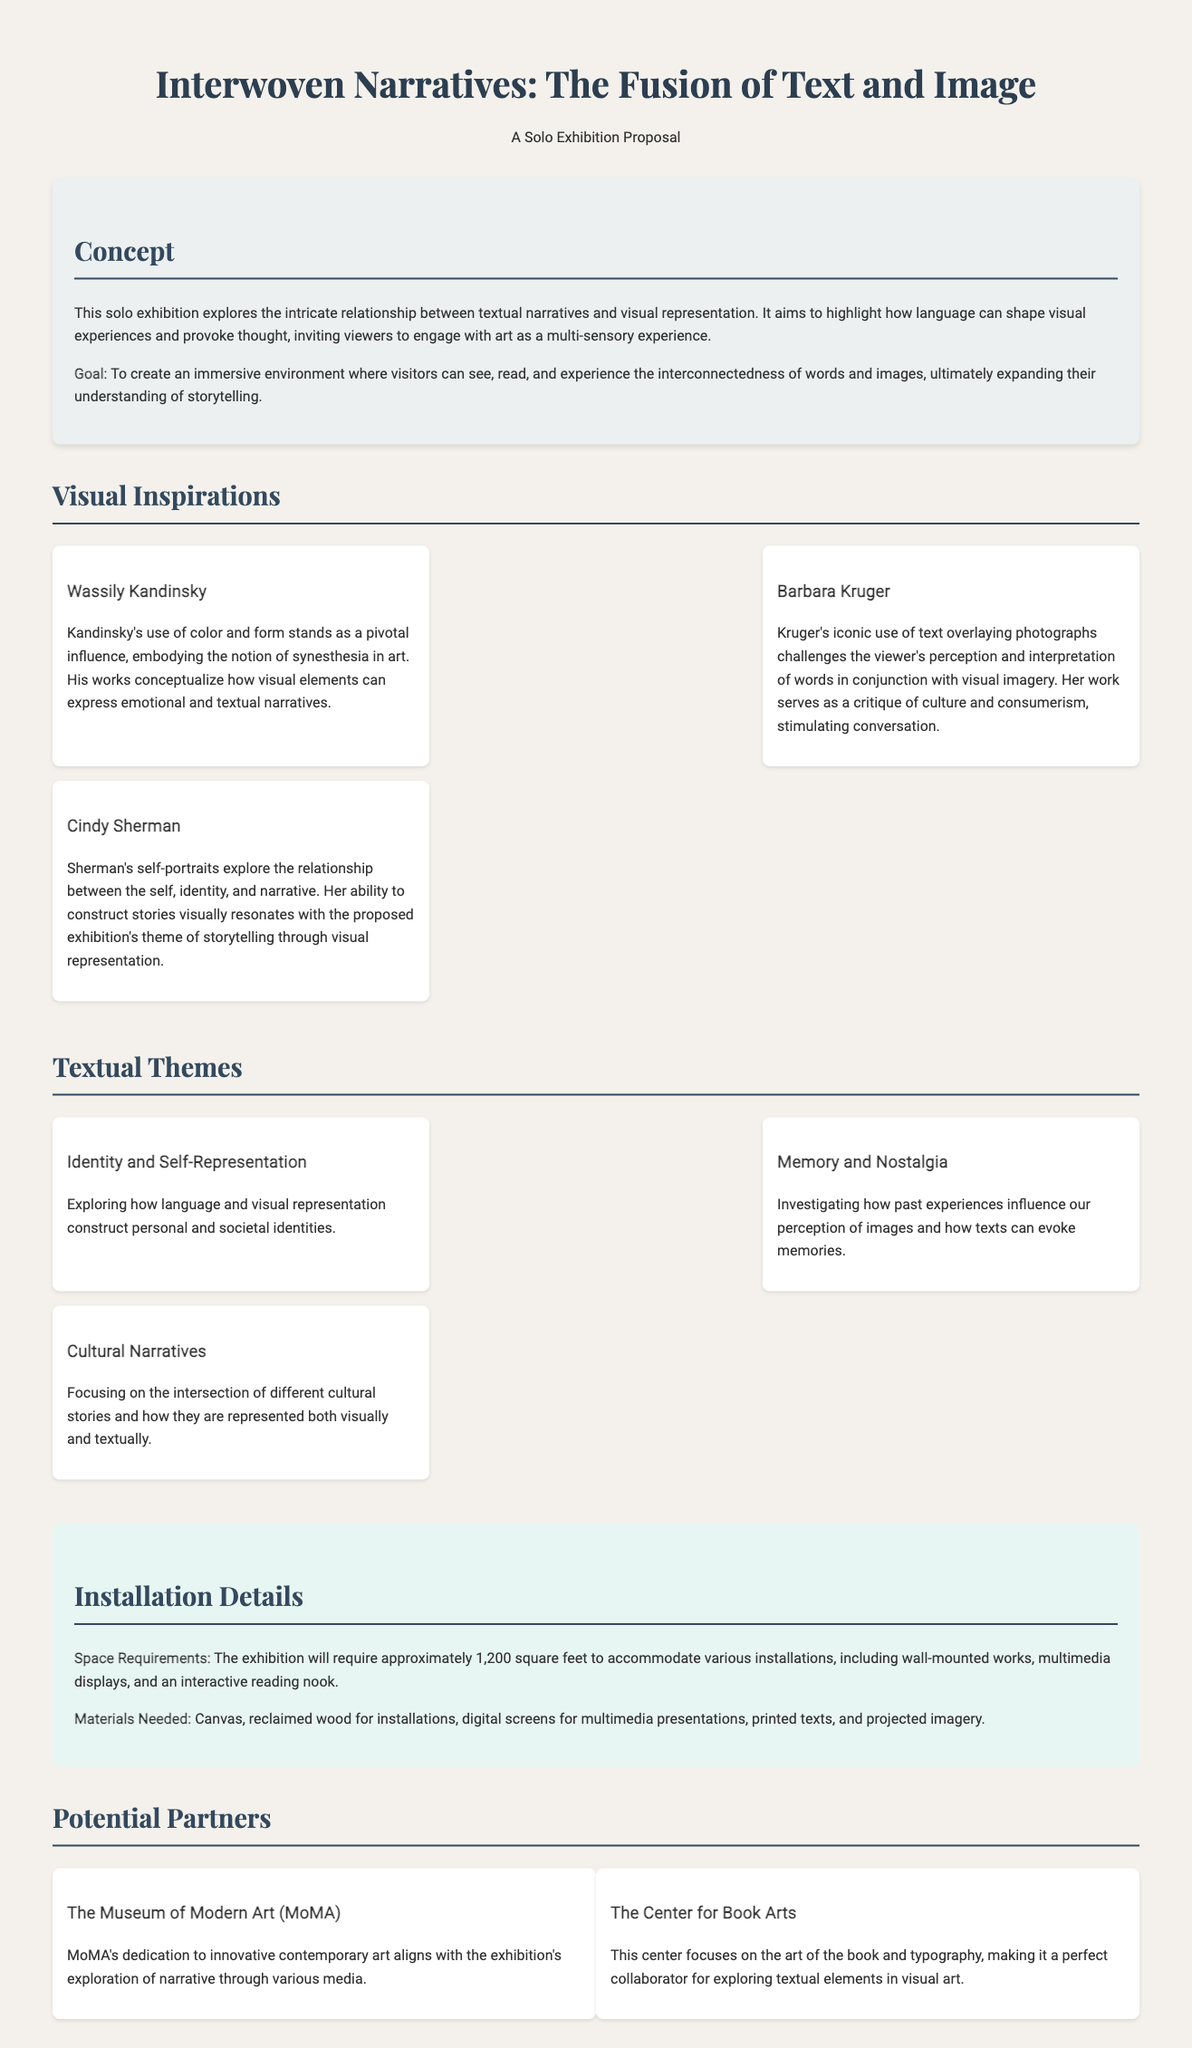What is the title of the exhibition? The title of the exhibition is stated at the beginning of the document.
Answer: Interwoven Narratives: The Fusion of Text and Image What is the main goal of the exhibition? The goal of the exhibition is outlined in the concept section, emphasizing visitor experience.
Answer: To create an immersive environment Who is one of the visual inspirations mentioned? The document lists several artists as visual inspirations, and one example is requested.
Answer: Wassily Kandinsky What are the space requirements for the exhibition? The installation details section provides specifics about the required space.
Answer: Approximately 1,200 square feet What theme is related to past experiences? The textual themes section describes various themes, including one focused on memories.
Answer: Memory and Nostalgia Which potential partner focuses on the art of the book? The partners section specifies organizations that could collaborate, with one related to books.
Answer: The Center for Book Arts What element does Barbara Kruger challenge in her work? The document describes Kruger's approach to art, focusing on a particular aspect of her critique.
Answer: Perception and interpretation What type of materials are needed for the installations? Installation details mention various materials required for the exhibition setup.
Answer: Canvas, reclaimed wood, digital screens, printed texts, projected imagery What aspect of identity does the exhibition explore? The textual themes section outlines how certain themes relate to identity and representation.
Answer: Identity and Self-Representation 